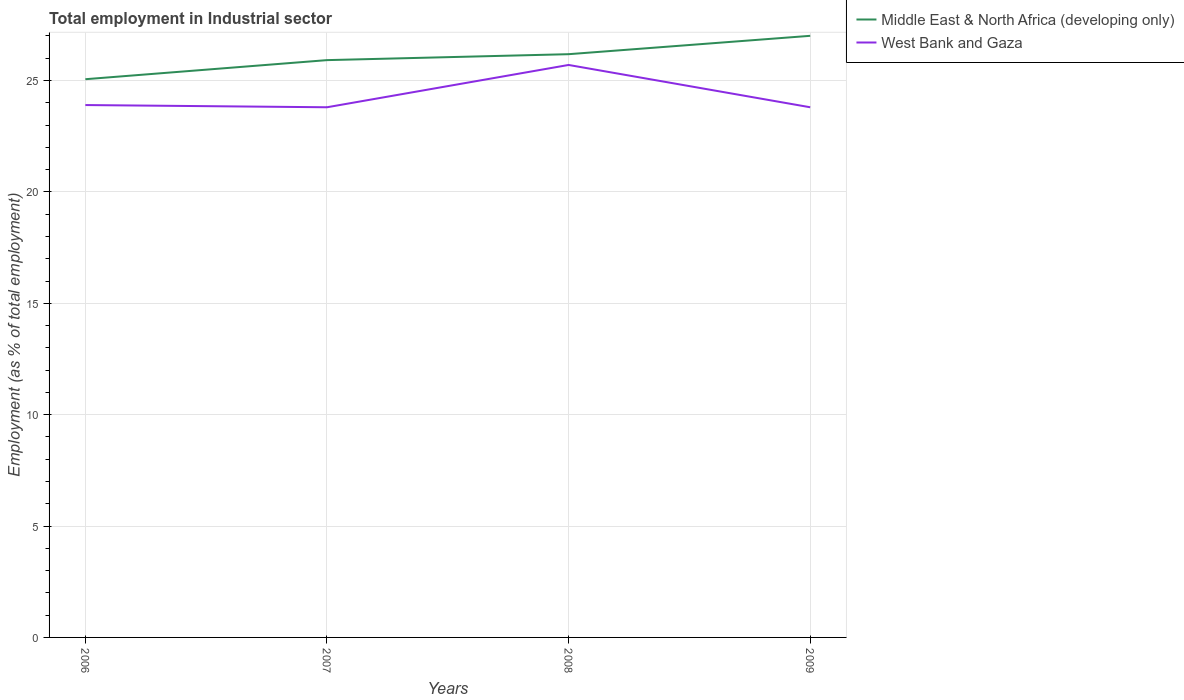How many different coloured lines are there?
Make the answer very short. 2. Does the line corresponding to West Bank and Gaza intersect with the line corresponding to Middle East & North Africa (developing only)?
Give a very brief answer. No. Is the number of lines equal to the number of legend labels?
Offer a terse response. Yes. Across all years, what is the maximum employment in industrial sector in West Bank and Gaza?
Provide a short and direct response. 23.8. What is the total employment in industrial sector in Middle East & North Africa (developing only) in the graph?
Ensure brevity in your answer.  -1.95. What is the difference between the highest and the second highest employment in industrial sector in Middle East & North Africa (developing only)?
Provide a succinct answer. 1.95. Is the employment in industrial sector in West Bank and Gaza strictly greater than the employment in industrial sector in Middle East & North Africa (developing only) over the years?
Offer a very short reply. Yes. How many lines are there?
Make the answer very short. 2. How many years are there in the graph?
Provide a short and direct response. 4. Are the values on the major ticks of Y-axis written in scientific E-notation?
Offer a very short reply. No. Does the graph contain any zero values?
Your answer should be compact. No. How many legend labels are there?
Your answer should be compact. 2. What is the title of the graph?
Your response must be concise. Total employment in Industrial sector. What is the label or title of the Y-axis?
Make the answer very short. Employment (as % of total employment). What is the Employment (as % of total employment) of Middle East & North Africa (developing only) in 2006?
Offer a very short reply. 25.06. What is the Employment (as % of total employment) of West Bank and Gaza in 2006?
Provide a succinct answer. 23.9. What is the Employment (as % of total employment) in Middle East & North Africa (developing only) in 2007?
Your answer should be very brief. 25.92. What is the Employment (as % of total employment) of West Bank and Gaza in 2007?
Your answer should be compact. 23.8. What is the Employment (as % of total employment) of Middle East & North Africa (developing only) in 2008?
Offer a very short reply. 26.18. What is the Employment (as % of total employment) of West Bank and Gaza in 2008?
Provide a succinct answer. 25.7. What is the Employment (as % of total employment) of Middle East & North Africa (developing only) in 2009?
Your answer should be compact. 27.01. What is the Employment (as % of total employment) of West Bank and Gaza in 2009?
Provide a short and direct response. 23.8. Across all years, what is the maximum Employment (as % of total employment) in Middle East & North Africa (developing only)?
Ensure brevity in your answer.  27.01. Across all years, what is the maximum Employment (as % of total employment) in West Bank and Gaza?
Your answer should be compact. 25.7. Across all years, what is the minimum Employment (as % of total employment) in Middle East & North Africa (developing only)?
Ensure brevity in your answer.  25.06. Across all years, what is the minimum Employment (as % of total employment) of West Bank and Gaza?
Keep it short and to the point. 23.8. What is the total Employment (as % of total employment) of Middle East & North Africa (developing only) in the graph?
Your answer should be very brief. 104.17. What is the total Employment (as % of total employment) in West Bank and Gaza in the graph?
Your response must be concise. 97.2. What is the difference between the Employment (as % of total employment) in Middle East & North Africa (developing only) in 2006 and that in 2007?
Provide a succinct answer. -0.86. What is the difference between the Employment (as % of total employment) in Middle East & North Africa (developing only) in 2006 and that in 2008?
Make the answer very short. -1.12. What is the difference between the Employment (as % of total employment) in Middle East & North Africa (developing only) in 2006 and that in 2009?
Keep it short and to the point. -1.95. What is the difference between the Employment (as % of total employment) in West Bank and Gaza in 2006 and that in 2009?
Your answer should be compact. 0.1. What is the difference between the Employment (as % of total employment) of Middle East & North Africa (developing only) in 2007 and that in 2008?
Your answer should be very brief. -0.27. What is the difference between the Employment (as % of total employment) in Middle East & North Africa (developing only) in 2007 and that in 2009?
Offer a terse response. -1.09. What is the difference between the Employment (as % of total employment) in West Bank and Gaza in 2007 and that in 2009?
Your response must be concise. 0. What is the difference between the Employment (as % of total employment) in Middle East & North Africa (developing only) in 2008 and that in 2009?
Your response must be concise. -0.82. What is the difference between the Employment (as % of total employment) in West Bank and Gaza in 2008 and that in 2009?
Make the answer very short. 1.9. What is the difference between the Employment (as % of total employment) of Middle East & North Africa (developing only) in 2006 and the Employment (as % of total employment) of West Bank and Gaza in 2007?
Provide a short and direct response. 1.26. What is the difference between the Employment (as % of total employment) in Middle East & North Africa (developing only) in 2006 and the Employment (as % of total employment) in West Bank and Gaza in 2008?
Provide a short and direct response. -0.64. What is the difference between the Employment (as % of total employment) of Middle East & North Africa (developing only) in 2006 and the Employment (as % of total employment) of West Bank and Gaza in 2009?
Provide a short and direct response. 1.26. What is the difference between the Employment (as % of total employment) of Middle East & North Africa (developing only) in 2007 and the Employment (as % of total employment) of West Bank and Gaza in 2008?
Ensure brevity in your answer.  0.22. What is the difference between the Employment (as % of total employment) in Middle East & North Africa (developing only) in 2007 and the Employment (as % of total employment) in West Bank and Gaza in 2009?
Offer a terse response. 2.12. What is the difference between the Employment (as % of total employment) of Middle East & North Africa (developing only) in 2008 and the Employment (as % of total employment) of West Bank and Gaza in 2009?
Offer a very short reply. 2.38. What is the average Employment (as % of total employment) in Middle East & North Africa (developing only) per year?
Ensure brevity in your answer.  26.04. What is the average Employment (as % of total employment) in West Bank and Gaza per year?
Your answer should be compact. 24.3. In the year 2006, what is the difference between the Employment (as % of total employment) in Middle East & North Africa (developing only) and Employment (as % of total employment) in West Bank and Gaza?
Provide a succinct answer. 1.16. In the year 2007, what is the difference between the Employment (as % of total employment) in Middle East & North Africa (developing only) and Employment (as % of total employment) in West Bank and Gaza?
Keep it short and to the point. 2.12. In the year 2008, what is the difference between the Employment (as % of total employment) of Middle East & North Africa (developing only) and Employment (as % of total employment) of West Bank and Gaza?
Give a very brief answer. 0.48. In the year 2009, what is the difference between the Employment (as % of total employment) of Middle East & North Africa (developing only) and Employment (as % of total employment) of West Bank and Gaza?
Offer a terse response. 3.21. What is the ratio of the Employment (as % of total employment) in Middle East & North Africa (developing only) in 2006 to that in 2007?
Your answer should be compact. 0.97. What is the ratio of the Employment (as % of total employment) in West Bank and Gaza in 2006 to that in 2007?
Give a very brief answer. 1. What is the ratio of the Employment (as % of total employment) in Middle East & North Africa (developing only) in 2006 to that in 2008?
Make the answer very short. 0.96. What is the ratio of the Employment (as % of total employment) in West Bank and Gaza in 2006 to that in 2008?
Provide a short and direct response. 0.93. What is the ratio of the Employment (as % of total employment) of Middle East & North Africa (developing only) in 2006 to that in 2009?
Provide a succinct answer. 0.93. What is the ratio of the Employment (as % of total employment) in Middle East & North Africa (developing only) in 2007 to that in 2008?
Your answer should be compact. 0.99. What is the ratio of the Employment (as % of total employment) of West Bank and Gaza in 2007 to that in 2008?
Ensure brevity in your answer.  0.93. What is the ratio of the Employment (as % of total employment) in Middle East & North Africa (developing only) in 2007 to that in 2009?
Offer a terse response. 0.96. What is the ratio of the Employment (as % of total employment) in West Bank and Gaza in 2007 to that in 2009?
Your answer should be compact. 1. What is the ratio of the Employment (as % of total employment) of Middle East & North Africa (developing only) in 2008 to that in 2009?
Provide a succinct answer. 0.97. What is the ratio of the Employment (as % of total employment) in West Bank and Gaza in 2008 to that in 2009?
Make the answer very short. 1.08. What is the difference between the highest and the second highest Employment (as % of total employment) in Middle East & North Africa (developing only)?
Your response must be concise. 0.82. What is the difference between the highest and the second highest Employment (as % of total employment) of West Bank and Gaza?
Your answer should be very brief. 1.8. What is the difference between the highest and the lowest Employment (as % of total employment) of Middle East & North Africa (developing only)?
Ensure brevity in your answer.  1.95. 